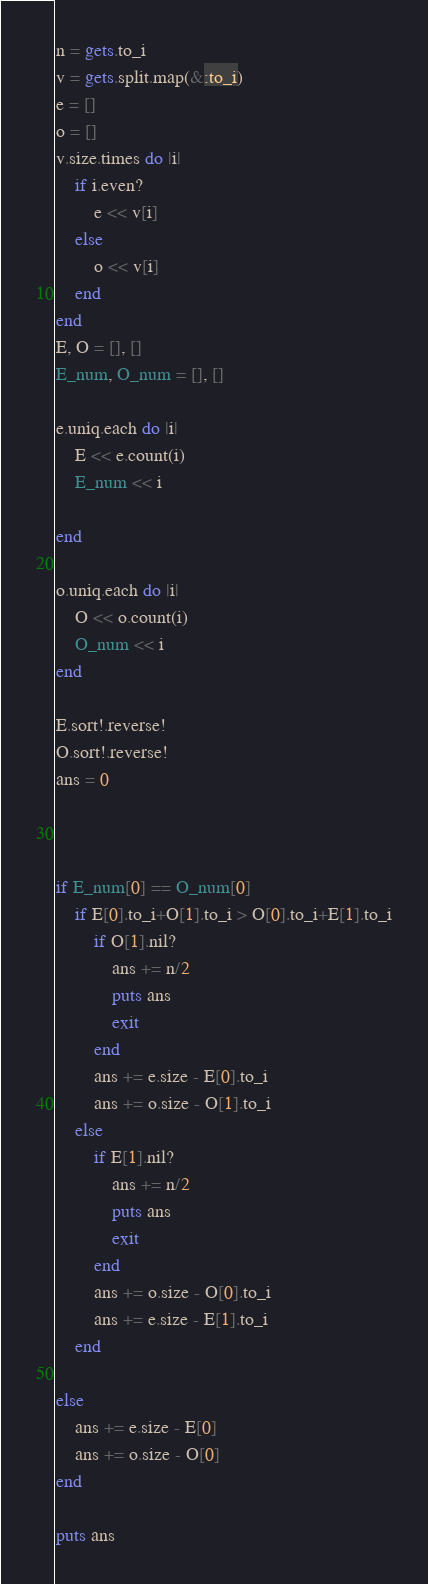<code> <loc_0><loc_0><loc_500><loc_500><_Ruby_>n = gets.to_i
v = gets.split.map(&:to_i)
e = []
o = []
v.size.times do |i|
	if i.even?
		e << v[i]
	else
		o << v[i]
	end
end
E, O = [], []
E_num, O_num = [], []

e.uniq.each do |i|
	E << e.count(i)
	E_num << i
	
end

o.uniq.each do |i|
	O << o.count(i)
	O_num << i
end

E.sort!.reverse!
O.sort!.reverse!
ans = 0



if E_num[0] == O_num[0]
	if E[0].to_i+O[1].to_i > O[0].to_i+E[1].to_i
		if O[1].nil?
			ans += n/2 
			puts ans
			exit
		end
		ans += e.size - E[0].to_i
		ans += o.size - O[1].to_i
	else
		if E[1].nil?
			ans += n/2
			puts ans
			exit
		end
		ans += o.size - O[0].to_i
		ans += e.size - E[1].to_i
	end

else
	ans += e.size - E[0]
	ans += o.size - O[0]
end

puts ans


</code> 